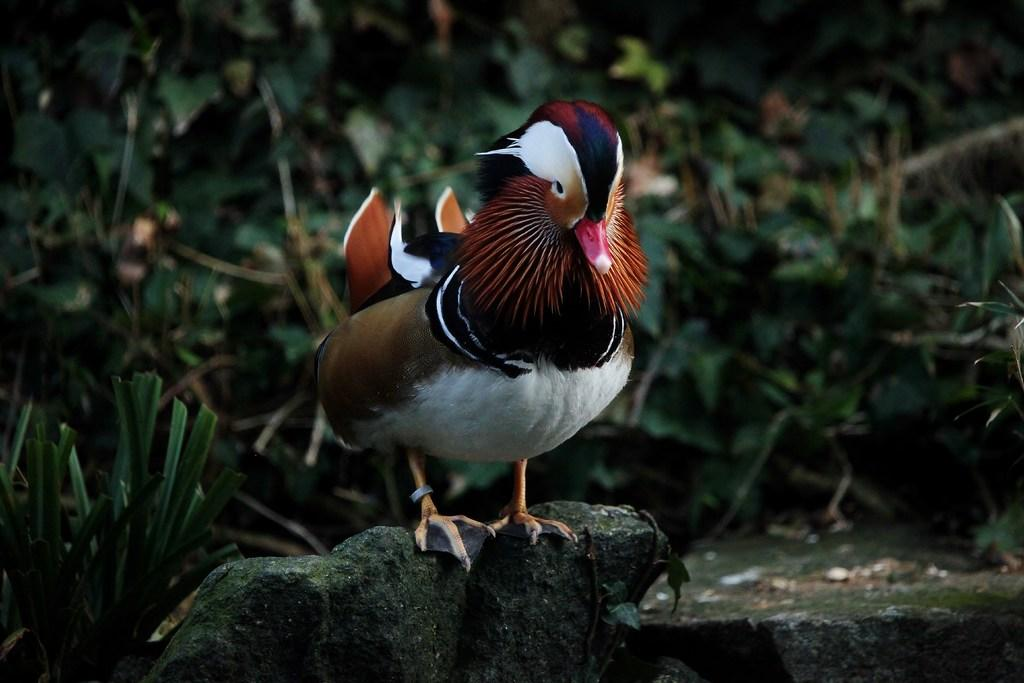What type of animal can be seen in the image? There is a bird in the image. Where is the bird located? The bird is standing on a rock. What can be seen in the background of the image? There are leaves visible in the background of the image. What type of legal advice can the bird provide in the image? The bird is not a lawyer and cannot provide legal advice in the image. 